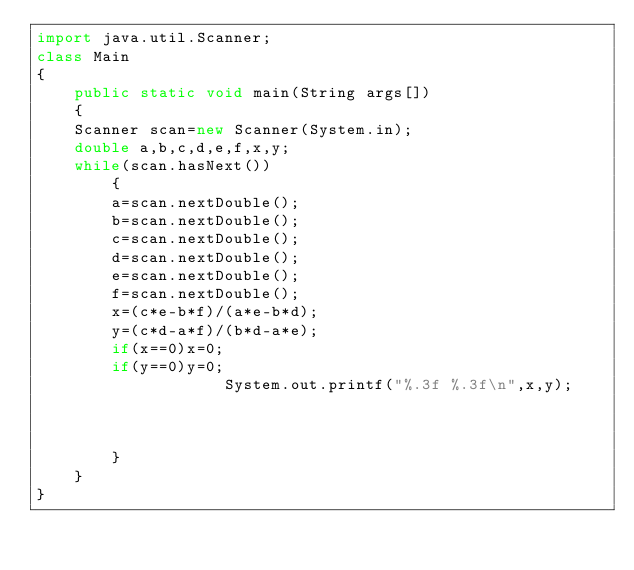Convert code to text. <code><loc_0><loc_0><loc_500><loc_500><_Java_>import java.util.Scanner;
class Main
{
    public static void main(String args[])
    {
	Scanner scan=new Scanner(System.in);
	double a,b,c,d,e,f,x,y;
	while(scan.hasNext())
	    {
		a=scan.nextDouble();
		b=scan.nextDouble();
		c=scan.nextDouble();
		d=scan.nextDouble();
		e=scan.nextDouble();
		f=scan.nextDouble();
		x=(c*e-b*f)/(a*e-b*d);
		y=(c*d-a*f)/(b*d-a*e);
		if(x==0)x=0;
		if(y==0)y=0;
					System.out.printf("%.3f %.3f\n",x,y);
				    
			    
		    
	    }
    }
}</code> 